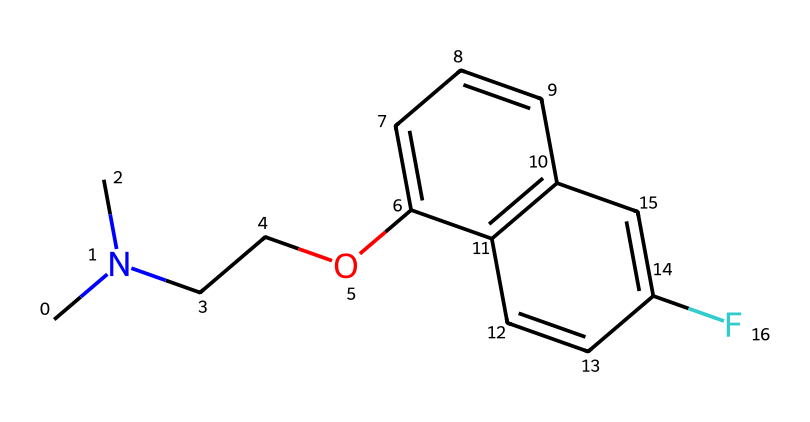What is the molecular formula of this compound? To determine the molecular formula, we count the number of each type of atom in the SMILES. The structure contains: 11 carbon (C), 12 hydrogen (H), 1 nitrogen (N), 1 fluorine (F), and 1 oxygen (O). Thus, the molecular formula is C11H12FNO.
Answer: C11H12FNO How many rings are present in the structure? By examining the SMILES, we can identify two cyclic parts as indicated by the repeated numbers (1 and 2) which denote the start and end of rings. Thus, there are two rings.
Answer: 2 What functional group is present in this drug? Looking at the structure, the presence of an ether (—O— connected between carbon chains) indicates the functional group. The molecular structure clearly shows an alkoxy group through the C—O—C linkage.
Answer: ether Which atom is likely to contribute to the quantum behavior affecting serotonin reuptake? The presence of nitrogen is significant as it is a common site for interactions in biological molecules and influences electronic properties, making it essential for quantum interactions in the neuronal context.
Answer: nitrogen Does this structure contain any halogen atoms? Evaluating the compound structure reveals a fluorine (F) atom, indicating the presence of a halogen in the compound. The fluorine affects its pharmacological properties.
Answer: yes What is the significance of the specified molecular weight in drug design? To determine the molecular weight, we sum the weights of all constituent atoms based on the molecular formula (C11H12FNO). The total comes to approximately 201.25 g/mol. This molecular weight plays a crucial role in absorption, distribution, metabolism, and excretion (ADME) of the drug.
Answer: 201.25 g/mol 